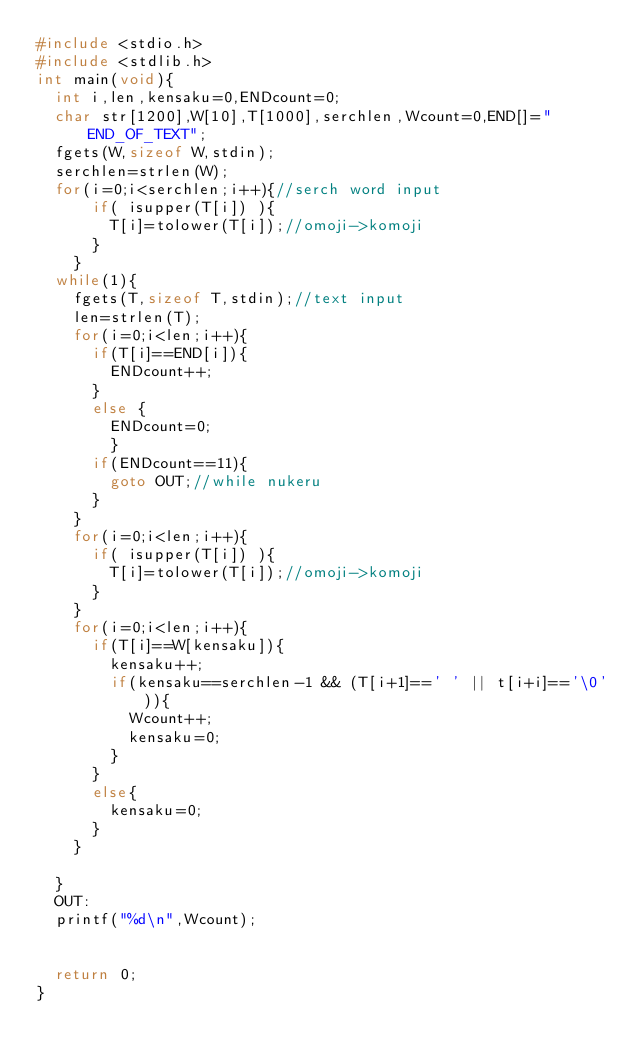<code> <loc_0><loc_0><loc_500><loc_500><_C_>#include <stdio.h>
#include <stdlib.h>
int main(void){
	int i,len,kensaku=0,ENDcount=0;
	char str[1200],W[10],T[1000],serchlen,Wcount=0,END[]="END_OF_TEXT";
	fgets(W,sizeof W,stdin);
	serchlen=strlen(W);
	for(i=0;i<serchlen;i++){//serch word input
			if( isupper(T[i]) ){
				T[i]=tolower(T[i]);//omoji->komoji
			}
		}
	while(1){
		fgets(T,sizeof T,stdin);//text input
		len=strlen(T);
		for(i=0;i<len;i++){
			if(T[i]==END[i]){
				ENDcount++;
			}
			else {
				ENDcount=0;
				}
			if(ENDcount==11){
				goto OUT;//while nukeru
			}
		}
		for(i=0;i<len;i++){
			if( isupper(T[i]) ){
				T[i]=tolower(T[i]);//omoji->komoji
			}
		}
		for(i=0;i<len;i++){
			if(T[i]==W[kensaku]){
				kensaku++;
				if(kensaku==serchlen-1 && (T[i+1]==' ' || t[i+i]=='\0')){
					Wcount++;
					kensaku=0;
				}
			}
			else{
				kensaku=0;
			}
		}
		
	}
	OUT:
	printf("%d\n",Wcount);
	
	
	return 0;
}</code> 